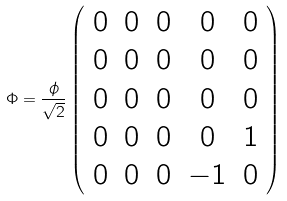<formula> <loc_0><loc_0><loc_500><loc_500>\Phi = \frac { \phi } { \sqrt { 2 } } \left ( \begin{array} { c c c c c } 0 & 0 & 0 & 0 & 0 \\ 0 & 0 & 0 & 0 & 0 \\ 0 & 0 & 0 & 0 & 0 \\ 0 & 0 & 0 & 0 & 1 \\ 0 & 0 & 0 & - 1 & 0 \end{array} \right )</formula> 